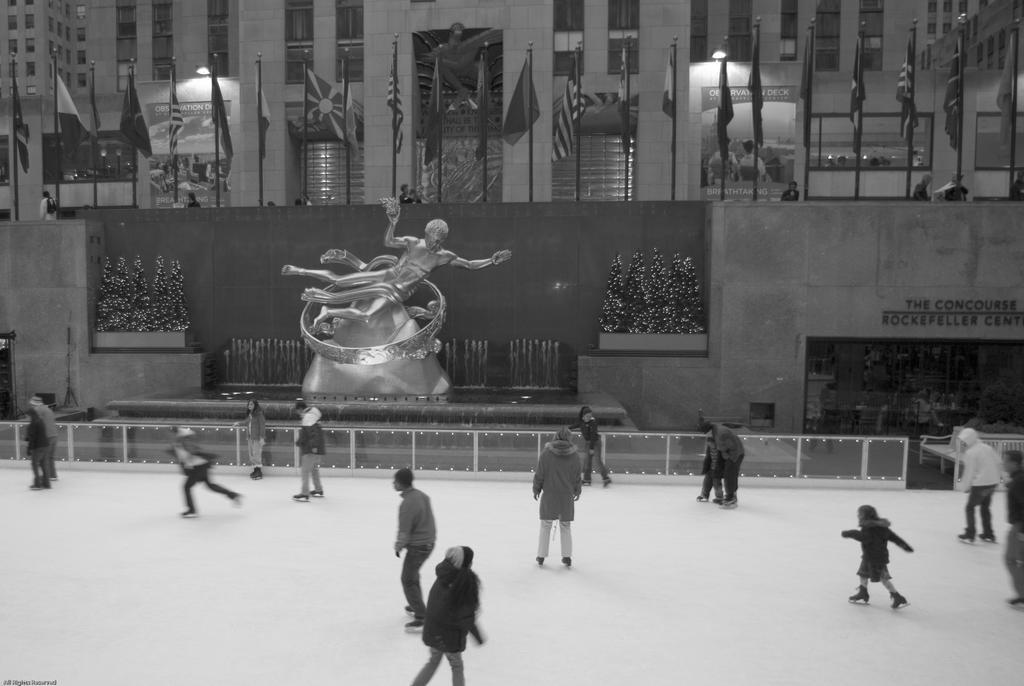Please provide a concise description of this image. This is a black and white image. In the image we can see there are people wearing clothes, cap and snow skiing shoes and they are riding on the snow. Here we can see a sculpture of a person, we can see planets and the flags. Here we can see the building and these are the windows of the building. 